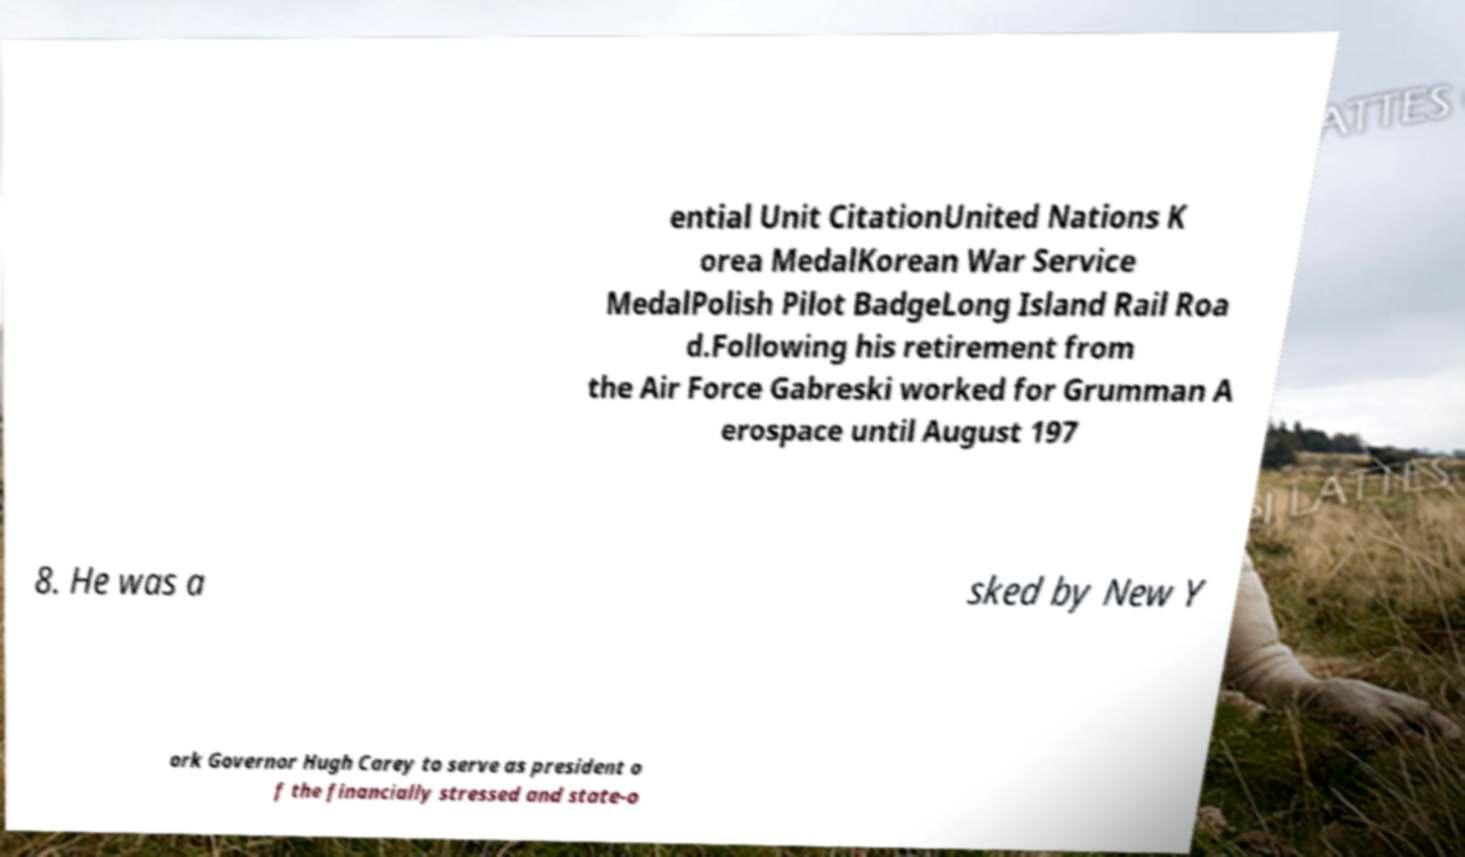Please identify and transcribe the text found in this image. ential Unit CitationUnited Nations K orea MedalKorean War Service MedalPolish Pilot BadgeLong Island Rail Roa d.Following his retirement from the Air Force Gabreski worked for Grumman A erospace until August 197 8. He was a sked by New Y ork Governor Hugh Carey to serve as president o f the financially stressed and state-o 